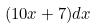<formula> <loc_0><loc_0><loc_500><loc_500>( 1 0 x + 7 ) d x</formula> 